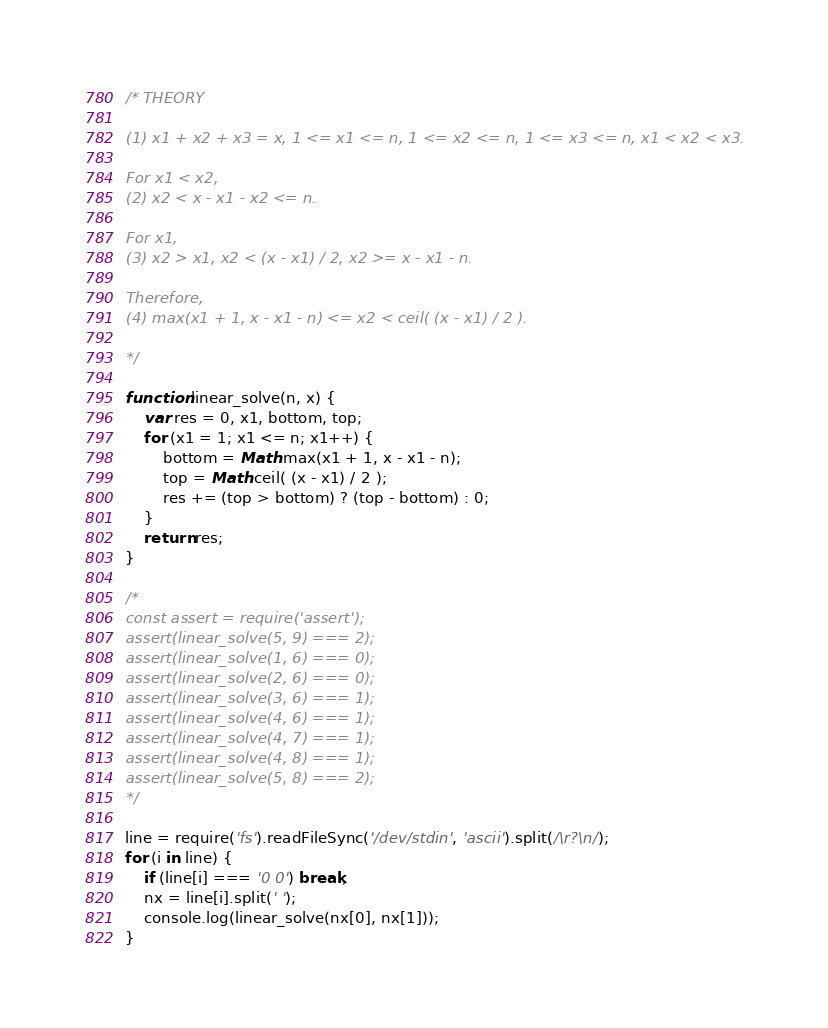Convert code to text. <code><loc_0><loc_0><loc_500><loc_500><_JavaScript_>/* THEORY

(1) x1 + x2 + x3 = x, 1 <= x1 <= n, 1 <= x2 <= n, 1 <= x3 <= n, x1 < x2 < x3.

For x1 < x2,
(2) x2 < x - x1 - x2 <= n.

For x1,
(3) x2 > x1, x2 < (x - x1) / 2, x2 >= x - x1 - n.

Therefore,
(4) max(x1 + 1, x - x1 - n) <= x2 < ceil( (x - x1) / 2 ).

*/

function linear_solve(n, x) {
	var res = 0, x1, bottom, top;
	for (x1 = 1; x1 <= n; x1++) {
		bottom = Math.max(x1 + 1, x - x1 - n);
		top = Math.ceil( (x - x1) / 2 );
		res += (top > bottom) ? (top - bottom) : 0;
	}
	return res;
}

/*
const assert = require('assert');
assert(linear_solve(5, 9) === 2);
assert(linear_solve(1, 6) === 0);
assert(linear_solve(2, 6) === 0);
assert(linear_solve(3, 6) === 1);
assert(linear_solve(4, 6) === 1);
assert(linear_solve(4, 7) === 1);
assert(linear_solve(4, 8) === 1);
assert(linear_solve(5, 8) === 2);
*/

line = require('fs').readFileSync('/dev/stdin', 'ascii').split(/\r?\n/);
for (i in line) {
	if (line[i] === '0 0') break;
	nx = line[i].split(' ');
	console.log(linear_solve(nx[0], nx[1]));
}</code> 